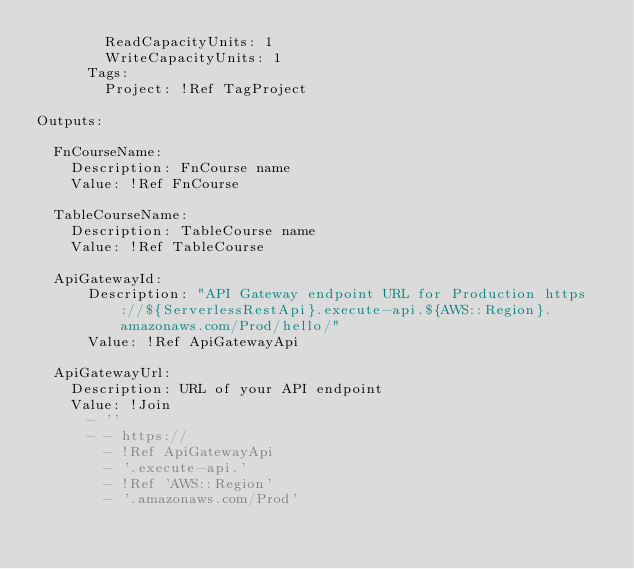<code> <loc_0><loc_0><loc_500><loc_500><_YAML_>        ReadCapacityUnits: 1
        WriteCapacityUnits: 1
      Tags:
        Project: !Ref TagProject
        
Outputs:

  FnCourseName:
    Description: FnCourse name
    Value: !Ref FnCourse

  TableCourseName:
    Description: TableCourse name
    Value: !Ref TableCourse

  ApiGatewayId:
      Description: "API Gateway endpoint URL for Production https://${ServerlessRestApi}.execute-api.${AWS::Region}.amazonaws.com/Prod/hello/"
      Value: !Ref ApiGatewayApi

  ApiGatewayUrl:
    Description: URL of your API endpoint
    Value: !Join
      - ''
      - - https://
        - !Ref ApiGatewayApi
        - '.execute-api.'
        - !Ref 'AWS::Region'
        - '.amazonaws.com/Prod'</code> 